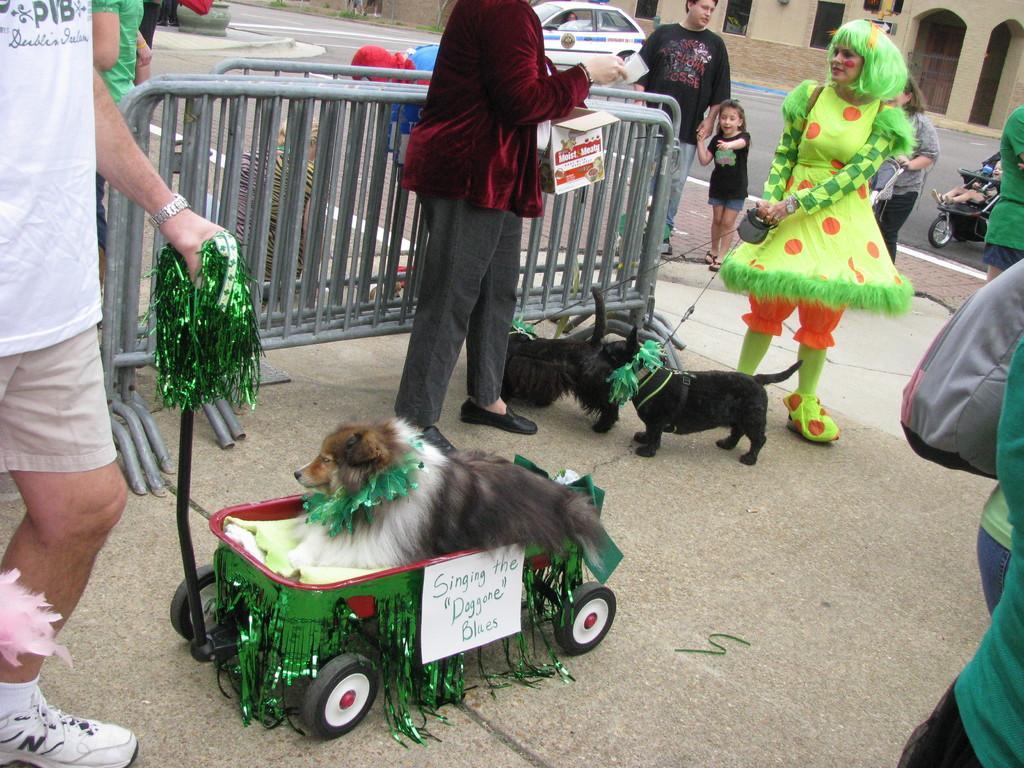Can you describe this image briefly? In the image on the floor there are few dogs and also there is a dog inside the stroller. On the left side of the image there is a man with white t-shirt is standing. And there are few people standing on the floor. And also there are fencing. In the background on the road there is a car. At the top of the image there is a building with walls and pillars. 